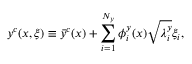Convert formula to latex. <formula><loc_0><loc_0><loc_500><loc_500>y ^ { c } ( x , \xi ) \equiv \bar { y } ^ { c } ( x ) + \sum _ { i = 1 } ^ { N _ { y } } \phi _ { i } ^ { y } ( x ) \sqrt { \lambda _ { i } ^ { y } } \xi _ { i } ,</formula> 